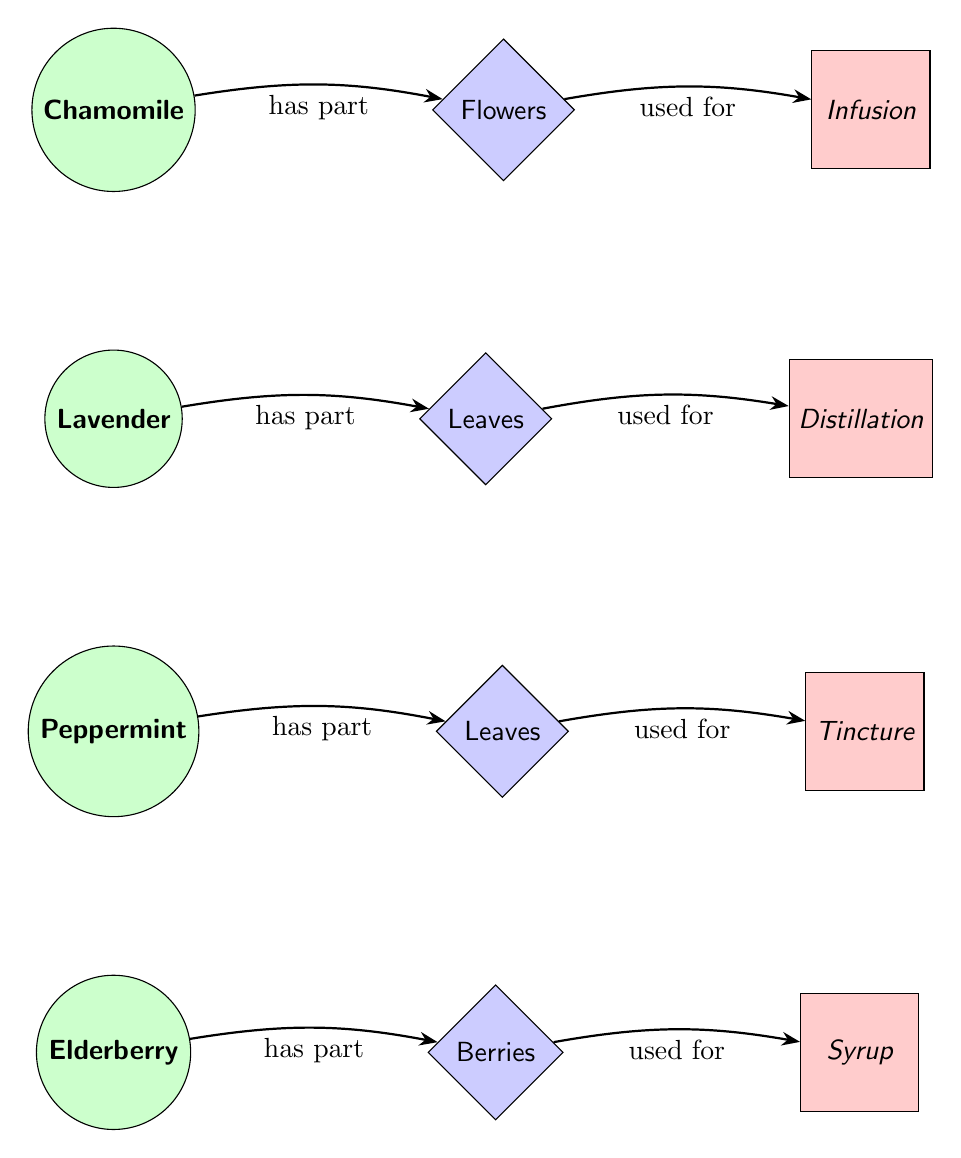What is the medicinal part of Chamomile? In the diagram, Chamomile has the part labeled "Flowers" indicated next to it. This shows the specific part of the plant used for treatment.
Answer: Flowers How many plants are represented in the diagram? The diagram includes four plants: Chamomile, Lavender, Peppermint, and Elderberry. Counting these gives a total of four plants.
Answer: 4 What method is used for Lavender? The diagram specifies "Distillation" as the preparation method linked to Lavender's leaves, indicating the way Lavender is prepared for medicinal use.
Answer: Distillation Which berries are used in Elderberry for treatment? The diagram shows "Berries" as the medicinal part of the Elderberry, indicating that the berries are specifically used for medicinal purposes.
Answer: Berries What is the preparation method for Peppermint? According to the diagram, Peppermint has "Tincture" listed as its method of preparation, showing how the leaves are used to create a medicinal product.
Answer: Tincture What is the relationship between Chamomile and Infusion? The diagram shows a directed edge from Chamomile leading to Flowers, and then from Flowers to Infusion, indicating that Chamomile's flowers are used to create an infusion.
Answer: has part, used for Which part of Elderberry is prepared into syrup? The diagram indicates that "Berries" from Elderberry are the specific part used to prepare "Syrup," directly linking the part to its preparation method.
Answer: Berries What is the connection between Peppermint and its leaves? The diagram shows that Peppermint "has part" labeled as "Leaves," which means the leaves are the relevant part of the plant for medicinal use.
Answer: Leaves What is the preparation method for Chamomile flowers? Based on the diagram, Chamomile's flowers are prepared using the method labeled "Infusion," indicating the specific treatment procedure.
Answer: Infusion 